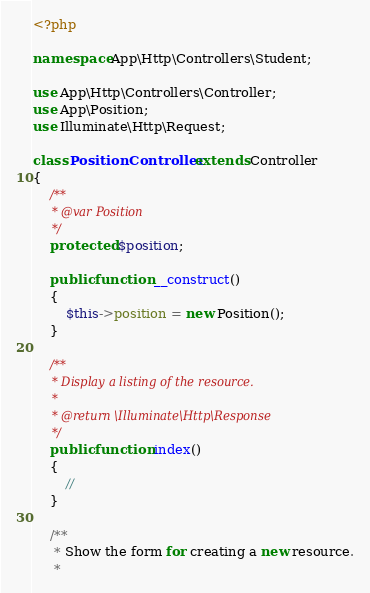<code> <loc_0><loc_0><loc_500><loc_500><_PHP_><?php

namespace App\Http\Controllers\Student;

use App\Http\Controllers\Controller;
use App\Position;
use Illuminate\Http\Request;

class PositionController extends Controller
{
    /**
     * @var Position
     */
    protected $position;

    public function __construct()
    {
        $this->position = new Position();
    }

    /**
     * Display a listing of the resource.
     *
     * @return \Illuminate\Http\Response
     */
    public function index()
    {
        //
    }

    /**
     * Show the form for creating a new resource.
     *</code> 